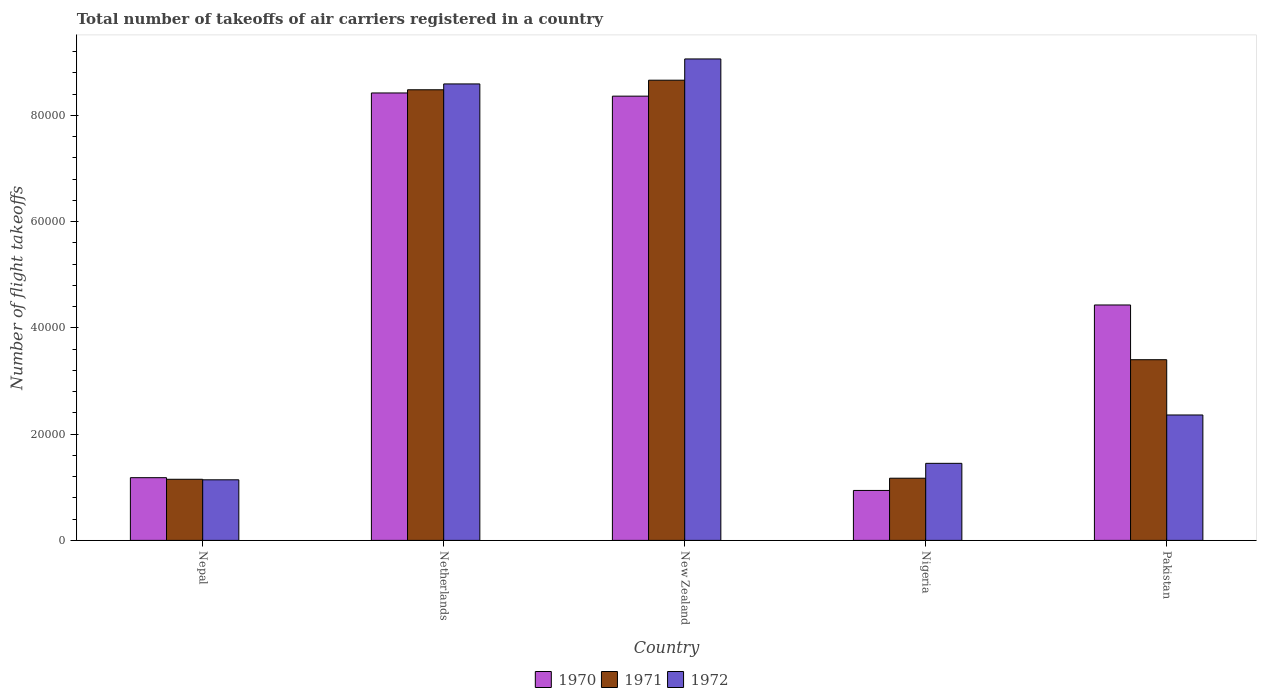How many different coloured bars are there?
Your answer should be compact. 3. Are the number of bars per tick equal to the number of legend labels?
Your answer should be very brief. Yes. How many bars are there on the 4th tick from the left?
Your response must be concise. 3. What is the label of the 2nd group of bars from the left?
Provide a short and direct response. Netherlands. What is the total number of flight takeoffs in 1971 in New Zealand?
Ensure brevity in your answer.  8.66e+04. Across all countries, what is the maximum total number of flight takeoffs in 1971?
Your response must be concise. 8.66e+04. Across all countries, what is the minimum total number of flight takeoffs in 1972?
Provide a short and direct response. 1.14e+04. In which country was the total number of flight takeoffs in 1971 maximum?
Ensure brevity in your answer.  New Zealand. In which country was the total number of flight takeoffs in 1971 minimum?
Make the answer very short. Nepal. What is the total total number of flight takeoffs in 1972 in the graph?
Ensure brevity in your answer.  2.26e+05. What is the difference between the total number of flight takeoffs in 1970 in Nepal and that in New Zealand?
Make the answer very short. -7.18e+04. What is the difference between the total number of flight takeoffs in 1971 in Nepal and the total number of flight takeoffs in 1970 in Pakistan?
Ensure brevity in your answer.  -3.28e+04. What is the average total number of flight takeoffs in 1971 per country?
Provide a succinct answer. 4.57e+04. What is the difference between the total number of flight takeoffs of/in 1972 and total number of flight takeoffs of/in 1970 in Pakistan?
Your answer should be very brief. -2.07e+04. What is the ratio of the total number of flight takeoffs in 1972 in Nigeria to that in Pakistan?
Ensure brevity in your answer.  0.61. Is the difference between the total number of flight takeoffs in 1972 in Netherlands and New Zealand greater than the difference between the total number of flight takeoffs in 1970 in Netherlands and New Zealand?
Provide a succinct answer. No. What is the difference between the highest and the second highest total number of flight takeoffs in 1970?
Keep it short and to the point. 3.99e+04. What is the difference between the highest and the lowest total number of flight takeoffs in 1971?
Your response must be concise. 7.51e+04. In how many countries, is the total number of flight takeoffs in 1970 greater than the average total number of flight takeoffs in 1970 taken over all countries?
Give a very brief answer. 2. Is the sum of the total number of flight takeoffs in 1971 in Netherlands and Nigeria greater than the maximum total number of flight takeoffs in 1970 across all countries?
Keep it short and to the point. Yes. How many countries are there in the graph?
Offer a very short reply. 5. Are the values on the major ticks of Y-axis written in scientific E-notation?
Make the answer very short. No. Does the graph contain grids?
Keep it short and to the point. No. Where does the legend appear in the graph?
Provide a short and direct response. Bottom center. How many legend labels are there?
Make the answer very short. 3. What is the title of the graph?
Your answer should be very brief. Total number of takeoffs of air carriers registered in a country. Does "1971" appear as one of the legend labels in the graph?
Give a very brief answer. Yes. What is the label or title of the X-axis?
Offer a very short reply. Country. What is the label or title of the Y-axis?
Your response must be concise. Number of flight takeoffs. What is the Number of flight takeoffs of 1970 in Nepal?
Ensure brevity in your answer.  1.18e+04. What is the Number of flight takeoffs of 1971 in Nepal?
Make the answer very short. 1.15e+04. What is the Number of flight takeoffs in 1972 in Nepal?
Your answer should be compact. 1.14e+04. What is the Number of flight takeoffs in 1970 in Netherlands?
Provide a short and direct response. 8.42e+04. What is the Number of flight takeoffs in 1971 in Netherlands?
Your response must be concise. 8.48e+04. What is the Number of flight takeoffs in 1972 in Netherlands?
Your answer should be very brief. 8.59e+04. What is the Number of flight takeoffs of 1970 in New Zealand?
Ensure brevity in your answer.  8.36e+04. What is the Number of flight takeoffs of 1971 in New Zealand?
Your response must be concise. 8.66e+04. What is the Number of flight takeoffs in 1972 in New Zealand?
Your response must be concise. 9.06e+04. What is the Number of flight takeoffs in 1970 in Nigeria?
Provide a short and direct response. 9400. What is the Number of flight takeoffs in 1971 in Nigeria?
Your answer should be very brief. 1.17e+04. What is the Number of flight takeoffs in 1972 in Nigeria?
Offer a terse response. 1.45e+04. What is the Number of flight takeoffs of 1970 in Pakistan?
Make the answer very short. 4.43e+04. What is the Number of flight takeoffs in 1971 in Pakistan?
Your response must be concise. 3.40e+04. What is the Number of flight takeoffs of 1972 in Pakistan?
Your answer should be compact. 2.36e+04. Across all countries, what is the maximum Number of flight takeoffs of 1970?
Offer a terse response. 8.42e+04. Across all countries, what is the maximum Number of flight takeoffs in 1971?
Provide a short and direct response. 8.66e+04. Across all countries, what is the maximum Number of flight takeoffs of 1972?
Keep it short and to the point. 9.06e+04. Across all countries, what is the minimum Number of flight takeoffs in 1970?
Provide a short and direct response. 9400. Across all countries, what is the minimum Number of flight takeoffs in 1971?
Keep it short and to the point. 1.15e+04. Across all countries, what is the minimum Number of flight takeoffs in 1972?
Ensure brevity in your answer.  1.14e+04. What is the total Number of flight takeoffs in 1970 in the graph?
Provide a short and direct response. 2.33e+05. What is the total Number of flight takeoffs in 1971 in the graph?
Your response must be concise. 2.29e+05. What is the total Number of flight takeoffs of 1972 in the graph?
Your answer should be very brief. 2.26e+05. What is the difference between the Number of flight takeoffs in 1970 in Nepal and that in Netherlands?
Make the answer very short. -7.24e+04. What is the difference between the Number of flight takeoffs in 1971 in Nepal and that in Netherlands?
Make the answer very short. -7.33e+04. What is the difference between the Number of flight takeoffs in 1972 in Nepal and that in Netherlands?
Your answer should be very brief. -7.45e+04. What is the difference between the Number of flight takeoffs of 1970 in Nepal and that in New Zealand?
Your answer should be compact. -7.18e+04. What is the difference between the Number of flight takeoffs in 1971 in Nepal and that in New Zealand?
Make the answer very short. -7.51e+04. What is the difference between the Number of flight takeoffs in 1972 in Nepal and that in New Zealand?
Ensure brevity in your answer.  -7.92e+04. What is the difference between the Number of flight takeoffs in 1970 in Nepal and that in Nigeria?
Provide a succinct answer. 2400. What is the difference between the Number of flight takeoffs in 1971 in Nepal and that in Nigeria?
Provide a succinct answer. -200. What is the difference between the Number of flight takeoffs in 1972 in Nepal and that in Nigeria?
Your answer should be compact. -3100. What is the difference between the Number of flight takeoffs of 1970 in Nepal and that in Pakistan?
Offer a very short reply. -3.25e+04. What is the difference between the Number of flight takeoffs in 1971 in Nepal and that in Pakistan?
Provide a short and direct response. -2.25e+04. What is the difference between the Number of flight takeoffs in 1972 in Nepal and that in Pakistan?
Keep it short and to the point. -1.22e+04. What is the difference between the Number of flight takeoffs of 1970 in Netherlands and that in New Zealand?
Give a very brief answer. 600. What is the difference between the Number of flight takeoffs in 1971 in Netherlands and that in New Zealand?
Your answer should be very brief. -1800. What is the difference between the Number of flight takeoffs of 1972 in Netherlands and that in New Zealand?
Offer a terse response. -4700. What is the difference between the Number of flight takeoffs of 1970 in Netherlands and that in Nigeria?
Your answer should be compact. 7.48e+04. What is the difference between the Number of flight takeoffs in 1971 in Netherlands and that in Nigeria?
Your response must be concise. 7.31e+04. What is the difference between the Number of flight takeoffs of 1972 in Netherlands and that in Nigeria?
Ensure brevity in your answer.  7.14e+04. What is the difference between the Number of flight takeoffs in 1970 in Netherlands and that in Pakistan?
Keep it short and to the point. 3.99e+04. What is the difference between the Number of flight takeoffs of 1971 in Netherlands and that in Pakistan?
Your answer should be compact. 5.08e+04. What is the difference between the Number of flight takeoffs in 1972 in Netherlands and that in Pakistan?
Ensure brevity in your answer.  6.23e+04. What is the difference between the Number of flight takeoffs in 1970 in New Zealand and that in Nigeria?
Provide a short and direct response. 7.42e+04. What is the difference between the Number of flight takeoffs in 1971 in New Zealand and that in Nigeria?
Ensure brevity in your answer.  7.49e+04. What is the difference between the Number of flight takeoffs of 1972 in New Zealand and that in Nigeria?
Provide a succinct answer. 7.61e+04. What is the difference between the Number of flight takeoffs in 1970 in New Zealand and that in Pakistan?
Offer a terse response. 3.93e+04. What is the difference between the Number of flight takeoffs in 1971 in New Zealand and that in Pakistan?
Ensure brevity in your answer.  5.26e+04. What is the difference between the Number of flight takeoffs of 1972 in New Zealand and that in Pakistan?
Ensure brevity in your answer.  6.70e+04. What is the difference between the Number of flight takeoffs in 1970 in Nigeria and that in Pakistan?
Your response must be concise. -3.49e+04. What is the difference between the Number of flight takeoffs in 1971 in Nigeria and that in Pakistan?
Keep it short and to the point. -2.23e+04. What is the difference between the Number of flight takeoffs of 1972 in Nigeria and that in Pakistan?
Offer a terse response. -9100. What is the difference between the Number of flight takeoffs in 1970 in Nepal and the Number of flight takeoffs in 1971 in Netherlands?
Give a very brief answer. -7.30e+04. What is the difference between the Number of flight takeoffs in 1970 in Nepal and the Number of flight takeoffs in 1972 in Netherlands?
Offer a very short reply. -7.41e+04. What is the difference between the Number of flight takeoffs in 1971 in Nepal and the Number of flight takeoffs in 1972 in Netherlands?
Make the answer very short. -7.44e+04. What is the difference between the Number of flight takeoffs of 1970 in Nepal and the Number of flight takeoffs of 1971 in New Zealand?
Provide a succinct answer. -7.48e+04. What is the difference between the Number of flight takeoffs in 1970 in Nepal and the Number of flight takeoffs in 1972 in New Zealand?
Your answer should be compact. -7.88e+04. What is the difference between the Number of flight takeoffs of 1971 in Nepal and the Number of flight takeoffs of 1972 in New Zealand?
Offer a terse response. -7.91e+04. What is the difference between the Number of flight takeoffs in 1970 in Nepal and the Number of flight takeoffs in 1972 in Nigeria?
Your answer should be very brief. -2700. What is the difference between the Number of flight takeoffs of 1971 in Nepal and the Number of flight takeoffs of 1972 in Nigeria?
Your answer should be compact. -3000. What is the difference between the Number of flight takeoffs of 1970 in Nepal and the Number of flight takeoffs of 1971 in Pakistan?
Your response must be concise. -2.22e+04. What is the difference between the Number of flight takeoffs in 1970 in Nepal and the Number of flight takeoffs in 1972 in Pakistan?
Keep it short and to the point. -1.18e+04. What is the difference between the Number of flight takeoffs in 1971 in Nepal and the Number of flight takeoffs in 1972 in Pakistan?
Make the answer very short. -1.21e+04. What is the difference between the Number of flight takeoffs in 1970 in Netherlands and the Number of flight takeoffs in 1971 in New Zealand?
Make the answer very short. -2400. What is the difference between the Number of flight takeoffs of 1970 in Netherlands and the Number of flight takeoffs of 1972 in New Zealand?
Your answer should be compact. -6400. What is the difference between the Number of flight takeoffs in 1971 in Netherlands and the Number of flight takeoffs in 1972 in New Zealand?
Provide a succinct answer. -5800. What is the difference between the Number of flight takeoffs of 1970 in Netherlands and the Number of flight takeoffs of 1971 in Nigeria?
Your response must be concise. 7.25e+04. What is the difference between the Number of flight takeoffs of 1970 in Netherlands and the Number of flight takeoffs of 1972 in Nigeria?
Offer a terse response. 6.97e+04. What is the difference between the Number of flight takeoffs in 1971 in Netherlands and the Number of flight takeoffs in 1972 in Nigeria?
Your answer should be compact. 7.03e+04. What is the difference between the Number of flight takeoffs in 1970 in Netherlands and the Number of flight takeoffs in 1971 in Pakistan?
Your answer should be very brief. 5.02e+04. What is the difference between the Number of flight takeoffs of 1970 in Netherlands and the Number of flight takeoffs of 1972 in Pakistan?
Offer a terse response. 6.06e+04. What is the difference between the Number of flight takeoffs of 1971 in Netherlands and the Number of flight takeoffs of 1972 in Pakistan?
Make the answer very short. 6.12e+04. What is the difference between the Number of flight takeoffs in 1970 in New Zealand and the Number of flight takeoffs in 1971 in Nigeria?
Keep it short and to the point. 7.19e+04. What is the difference between the Number of flight takeoffs in 1970 in New Zealand and the Number of flight takeoffs in 1972 in Nigeria?
Offer a very short reply. 6.91e+04. What is the difference between the Number of flight takeoffs in 1971 in New Zealand and the Number of flight takeoffs in 1972 in Nigeria?
Your answer should be compact. 7.21e+04. What is the difference between the Number of flight takeoffs of 1970 in New Zealand and the Number of flight takeoffs of 1971 in Pakistan?
Offer a terse response. 4.96e+04. What is the difference between the Number of flight takeoffs of 1971 in New Zealand and the Number of flight takeoffs of 1972 in Pakistan?
Give a very brief answer. 6.30e+04. What is the difference between the Number of flight takeoffs in 1970 in Nigeria and the Number of flight takeoffs in 1971 in Pakistan?
Offer a terse response. -2.46e+04. What is the difference between the Number of flight takeoffs of 1970 in Nigeria and the Number of flight takeoffs of 1972 in Pakistan?
Provide a short and direct response. -1.42e+04. What is the difference between the Number of flight takeoffs of 1971 in Nigeria and the Number of flight takeoffs of 1972 in Pakistan?
Keep it short and to the point. -1.19e+04. What is the average Number of flight takeoffs of 1970 per country?
Provide a succinct answer. 4.67e+04. What is the average Number of flight takeoffs in 1971 per country?
Your answer should be compact. 4.57e+04. What is the average Number of flight takeoffs of 1972 per country?
Your response must be concise. 4.52e+04. What is the difference between the Number of flight takeoffs in 1970 and Number of flight takeoffs in 1971 in Nepal?
Ensure brevity in your answer.  300. What is the difference between the Number of flight takeoffs in 1970 and Number of flight takeoffs in 1972 in Nepal?
Provide a short and direct response. 400. What is the difference between the Number of flight takeoffs in 1970 and Number of flight takeoffs in 1971 in Netherlands?
Offer a very short reply. -600. What is the difference between the Number of flight takeoffs in 1970 and Number of flight takeoffs in 1972 in Netherlands?
Offer a terse response. -1700. What is the difference between the Number of flight takeoffs in 1971 and Number of flight takeoffs in 1972 in Netherlands?
Offer a very short reply. -1100. What is the difference between the Number of flight takeoffs of 1970 and Number of flight takeoffs of 1971 in New Zealand?
Ensure brevity in your answer.  -3000. What is the difference between the Number of flight takeoffs in 1970 and Number of flight takeoffs in 1972 in New Zealand?
Provide a short and direct response. -7000. What is the difference between the Number of flight takeoffs in 1971 and Number of flight takeoffs in 1972 in New Zealand?
Offer a very short reply. -4000. What is the difference between the Number of flight takeoffs in 1970 and Number of flight takeoffs in 1971 in Nigeria?
Provide a short and direct response. -2300. What is the difference between the Number of flight takeoffs of 1970 and Number of flight takeoffs of 1972 in Nigeria?
Offer a terse response. -5100. What is the difference between the Number of flight takeoffs in 1971 and Number of flight takeoffs in 1972 in Nigeria?
Your answer should be compact. -2800. What is the difference between the Number of flight takeoffs of 1970 and Number of flight takeoffs of 1971 in Pakistan?
Your answer should be very brief. 1.03e+04. What is the difference between the Number of flight takeoffs of 1970 and Number of flight takeoffs of 1972 in Pakistan?
Your answer should be compact. 2.07e+04. What is the difference between the Number of flight takeoffs in 1971 and Number of flight takeoffs in 1972 in Pakistan?
Your answer should be compact. 1.04e+04. What is the ratio of the Number of flight takeoffs in 1970 in Nepal to that in Netherlands?
Ensure brevity in your answer.  0.14. What is the ratio of the Number of flight takeoffs of 1971 in Nepal to that in Netherlands?
Offer a very short reply. 0.14. What is the ratio of the Number of flight takeoffs in 1972 in Nepal to that in Netherlands?
Offer a terse response. 0.13. What is the ratio of the Number of flight takeoffs in 1970 in Nepal to that in New Zealand?
Give a very brief answer. 0.14. What is the ratio of the Number of flight takeoffs of 1971 in Nepal to that in New Zealand?
Provide a succinct answer. 0.13. What is the ratio of the Number of flight takeoffs of 1972 in Nepal to that in New Zealand?
Provide a succinct answer. 0.13. What is the ratio of the Number of flight takeoffs in 1970 in Nepal to that in Nigeria?
Offer a very short reply. 1.26. What is the ratio of the Number of flight takeoffs in 1971 in Nepal to that in Nigeria?
Make the answer very short. 0.98. What is the ratio of the Number of flight takeoffs in 1972 in Nepal to that in Nigeria?
Offer a terse response. 0.79. What is the ratio of the Number of flight takeoffs in 1970 in Nepal to that in Pakistan?
Give a very brief answer. 0.27. What is the ratio of the Number of flight takeoffs in 1971 in Nepal to that in Pakistan?
Give a very brief answer. 0.34. What is the ratio of the Number of flight takeoffs of 1972 in Nepal to that in Pakistan?
Your response must be concise. 0.48. What is the ratio of the Number of flight takeoffs in 1971 in Netherlands to that in New Zealand?
Keep it short and to the point. 0.98. What is the ratio of the Number of flight takeoffs in 1972 in Netherlands to that in New Zealand?
Offer a terse response. 0.95. What is the ratio of the Number of flight takeoffs in 1970 in Netherlands to that in Nigeria?
Your answer should be very brief. 8.96. What is the ratio of the Number of flight takeoffs in 1971 in Netherlands to that in Nigeria?
Ensure brevity in your answer.  7.25. What is the ratio of the Number of flight takeoffs of 1972 in Netherlands to that in Nigeria?
Your answer should be very brief. 5.92. What is the ratio of the Number of flight takeoffs of 1970 in Netherlands to that in Pakistan?
Provide a short and direct response. 1.9. What is the ratio of the Number of flight takeoffs of 1971 in Netherlands to that in Pakistan?
Provide a short and direct response. 2.49. What is the ratio of the Number of flight takeoffs in 1972 in Netherlands to that in Pakistan?
Make the answer very short. 3.64. What is the ratio of the Number of flight takeoffs of 1970 in New Zealand to that in Nigeria?
Offer a terse response. 8.89. What is the ratio of the Number of flight takeoffs of 1971 in New Zealand to that in Nigeria?
Give a very brief answer. 7.4. What is the ratio of the Number of flight takeoffs of 1972 in New Zealand to that in Nigeria?
Provide a short and direct response. 6.25. What is the ratio of the Number of flight takeoffs in 1970 in New Zealand to that in Pakistan?
Provide a short and direct response. 1.89. What is the ratio of the Number of flight takeoffs in 1971 in New Zealand to that in Pakistan?
Your response must be concise. 2.55. What is the ratio of the Number of flight takeoffs of 1972 in New Zealand to that in Pakistan?
Your response must be concise. 3.84. What is the ratio of the Number of flight takeoffs of 1970 in Nigeria to that in Pakistan?
Your answer should be very brief. 0.21. What is the ratio of the Number of flight takeoffs of 1971 in Nigeria to that in Pakistan?
Your answer should be compact. 0.34. What is the ratio of the Number of flight takeoffs in 1972 in Nigeria to that in Pakistan?
Provide a short and direct response. 0.61. What is the difference between the highest and the second highest Number of flight takeoffs of 1970?
Your answer should be compact. 600. What is the difference between the highest and the second highest Number of flight takeoffs of 1971?
Ensure brevity in your answer.  1800. What is the difference between the highest and the second highest Number of flight takeoffs in 1972?
Your answer should be very brief. 4700. What is the difference between the highest and the lowest Number of flight takeoffs in 1970?
Provide a short and direct response. 7.48e+04. What is the difference between the highest and the lowest Number of flight takeoffs of 1971?
Offer a very short reply. 7.51e+04. What is the difference between the highest and the lowest Number of flight takeoffs in 1972?
Offer a very short reply. 7.92e+04. 